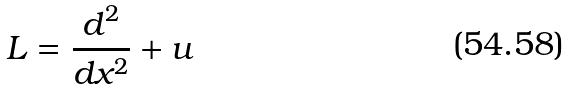Convert formula to latex. <formula><loc_0><loc_0><loc_500><loc_500>L = \frac { d ^ { 2 } } { d x ^ { 2 } } + u</formula> 